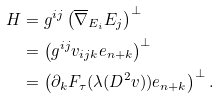Convert formula to latex. <formula><loc_0><loc_0><loc_500><loc_500>H & = g ^ { i j } \left ( \overline { \nabla } _ { E _ { i } } { E _ { j } } \right ) ^ { \perp } \\ & = \left ( g ^ { i j } v _ { i j k } e _ { n + k } \right ) ^ { \perp } \\ & = \left ( \partial _ { k } F _ { \tau } ( \lambda ( D ^ { 2 } v ) ) e _ { n + k } \right ) ^ { \perp } .</formula> 